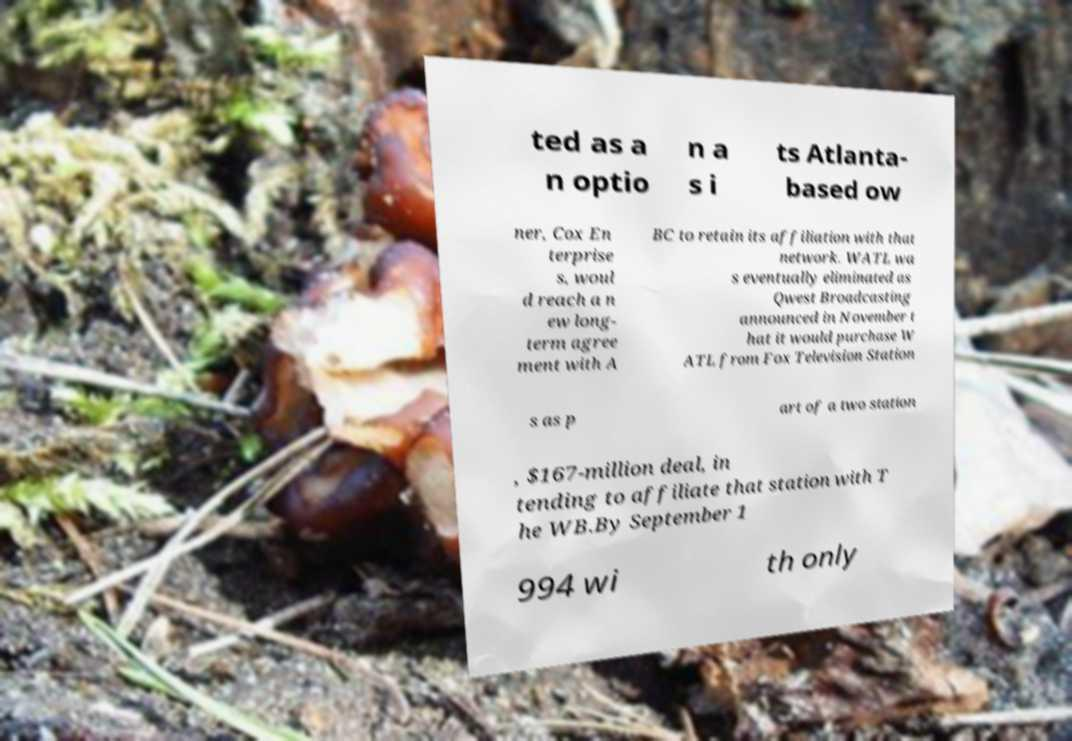Could you assist in decoding the text presented in this image and type it out clearly? ted as a n optio n a s i ts Atlanta- based ow ner, Cox En terprise s, woul d reach a n ew long- term agree ment with A BC to retain its affiliation with that network. WATL wa s eventually eliminated as Qwest Broadcasting announced in November t hat it would purchase W ATL from Fox Television Station s as p art of a two station , $167-million deal, in tending to affiliate that station with T he WB.By September 1 994 wi th only 